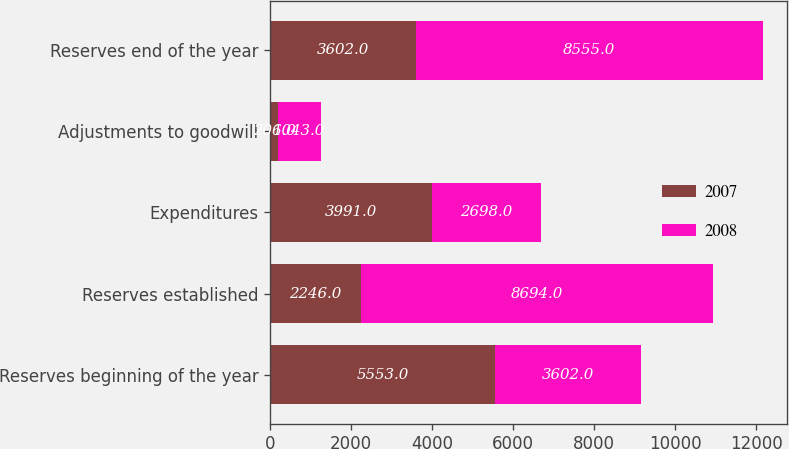Convert chart. <chart><loc_0><loc_0><loc_500><loc_500><stacked_bar_chart><ecel><fcel>Reserves beginning of the year<fcel>Reserves established<fcel>Expenditures<fcel>Adjustments to goodwill<fcel>Reserves end of the year<nl><fcel>2007<fcel>5553<fcel>2246<fcel>3991<fcel>206<fcel>3602<nl><fcel>2008<fcel>3602<fcel>8694<fcel>2698<fcel>1043<fcel>8555<nl></chart> 